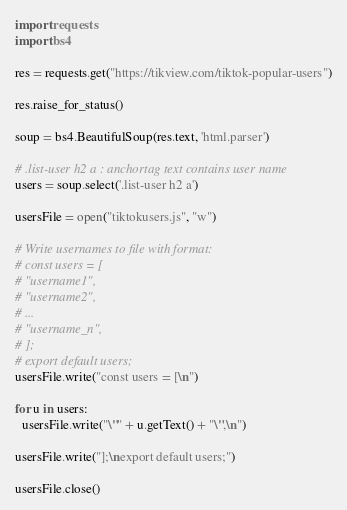<code> <loc_0><loc_0><loc_500><loc_500><_Python_>import requests
import bs4

res = requests.get("https://tikview.com/tiktok-popular-users")

res.raise_for_status()

soup = bs4.BeautifulSoup(res.text, 'html.parser')

# .list-user h2 a : anchortag text contains user name
users = soup.select('.list-user h2 a')

usersFile = open("tiktokusers.js", "w")

# Write usernames to file with format:
# const users = [
# "username1",
# "username2",
# ...
# "username_n",
# ];
# export default users;
usersFile.write("const users = [\n")

for u in users:
  usersFile.write("\"" + u.getText() + "\",\n")

usersFile.write("];\nexport default users;")

usersFile.close()</code> 